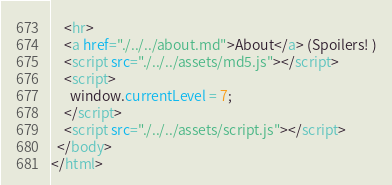Convert code to text. <code><loc_0><loc_0><loc_500><loc_500><_HTML_>    <hr>
    <a href="./../../about.md">About</a> (Spoilers! )
    <script src="./../../assets/md5.js"></script>
    <script>
      window.currentLevel = 7;
    </script>
    <script src="./../../assets/script.js"></script>
  </body>
</html></code> 